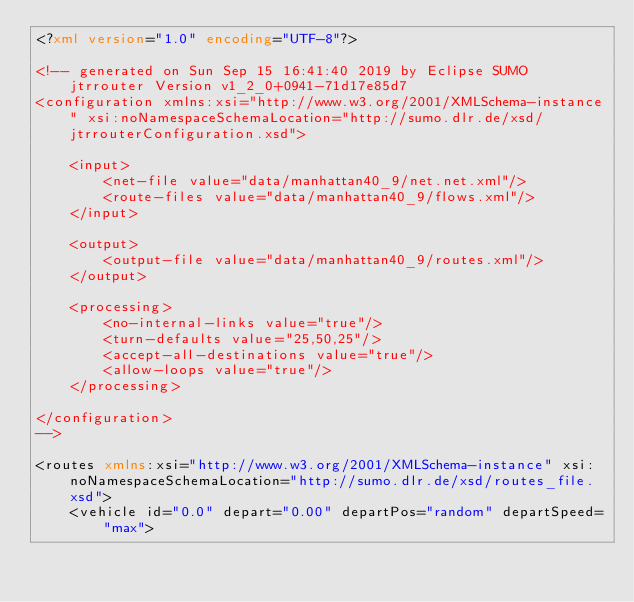<code> <loc_0><loc_0><loc_500><loc_500><_XML_><?xml version="1.0" encoding="UTF-8"?>

<!-- generated on Sun Sep 15 16:41:40 2019 by Eclipse SUMO jtrrouter Version v1_2_0+0941-71d17e85d7
<configuration xmlns:xsi="http://www.w3.org/2001/XMLSchema-instance" xsi:noNamespaceSchemaLocation="http://sumo.dlr.de/xsd/jtrrouterConfiguration.xsd">

    <input>
        <net-file value="data/manhattan40_9/net.net.xml"/>
        <route-files value="data/manhattan40_9/flows.xml"/>
    </input>

    <output>
        <output-file value="data/manhattan40_9/routes.xml"/>
    </output>

    <processing>
        <no-internal-links value="true"/>
        <turn-defaults value="25,50,25"/>
        <accept-all-destinations value="true"/>
        <allow-loops value="true"/>
    </processing>

</configuration>
-->

<routes xmlns:xsi="http://www.w3.org/2001/XMLSchema-instance" xsi:noNamespaceSchemaLocation="http://sumo.dlr.de/xsd/routes_file.xsd">
    <vehicle id="0.0" depart="0.00" departPos="random" departSpeed="max"></code> 